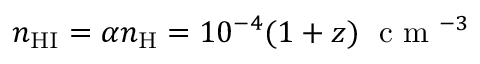<formula> <loc_0><loc_0><loc_500><loc_500>n _ { H I } = \alpha n _ { H } = 1 0 ^ { - 4 } ( 1 + z ) \, c m ^ { - 3 }</formula> 